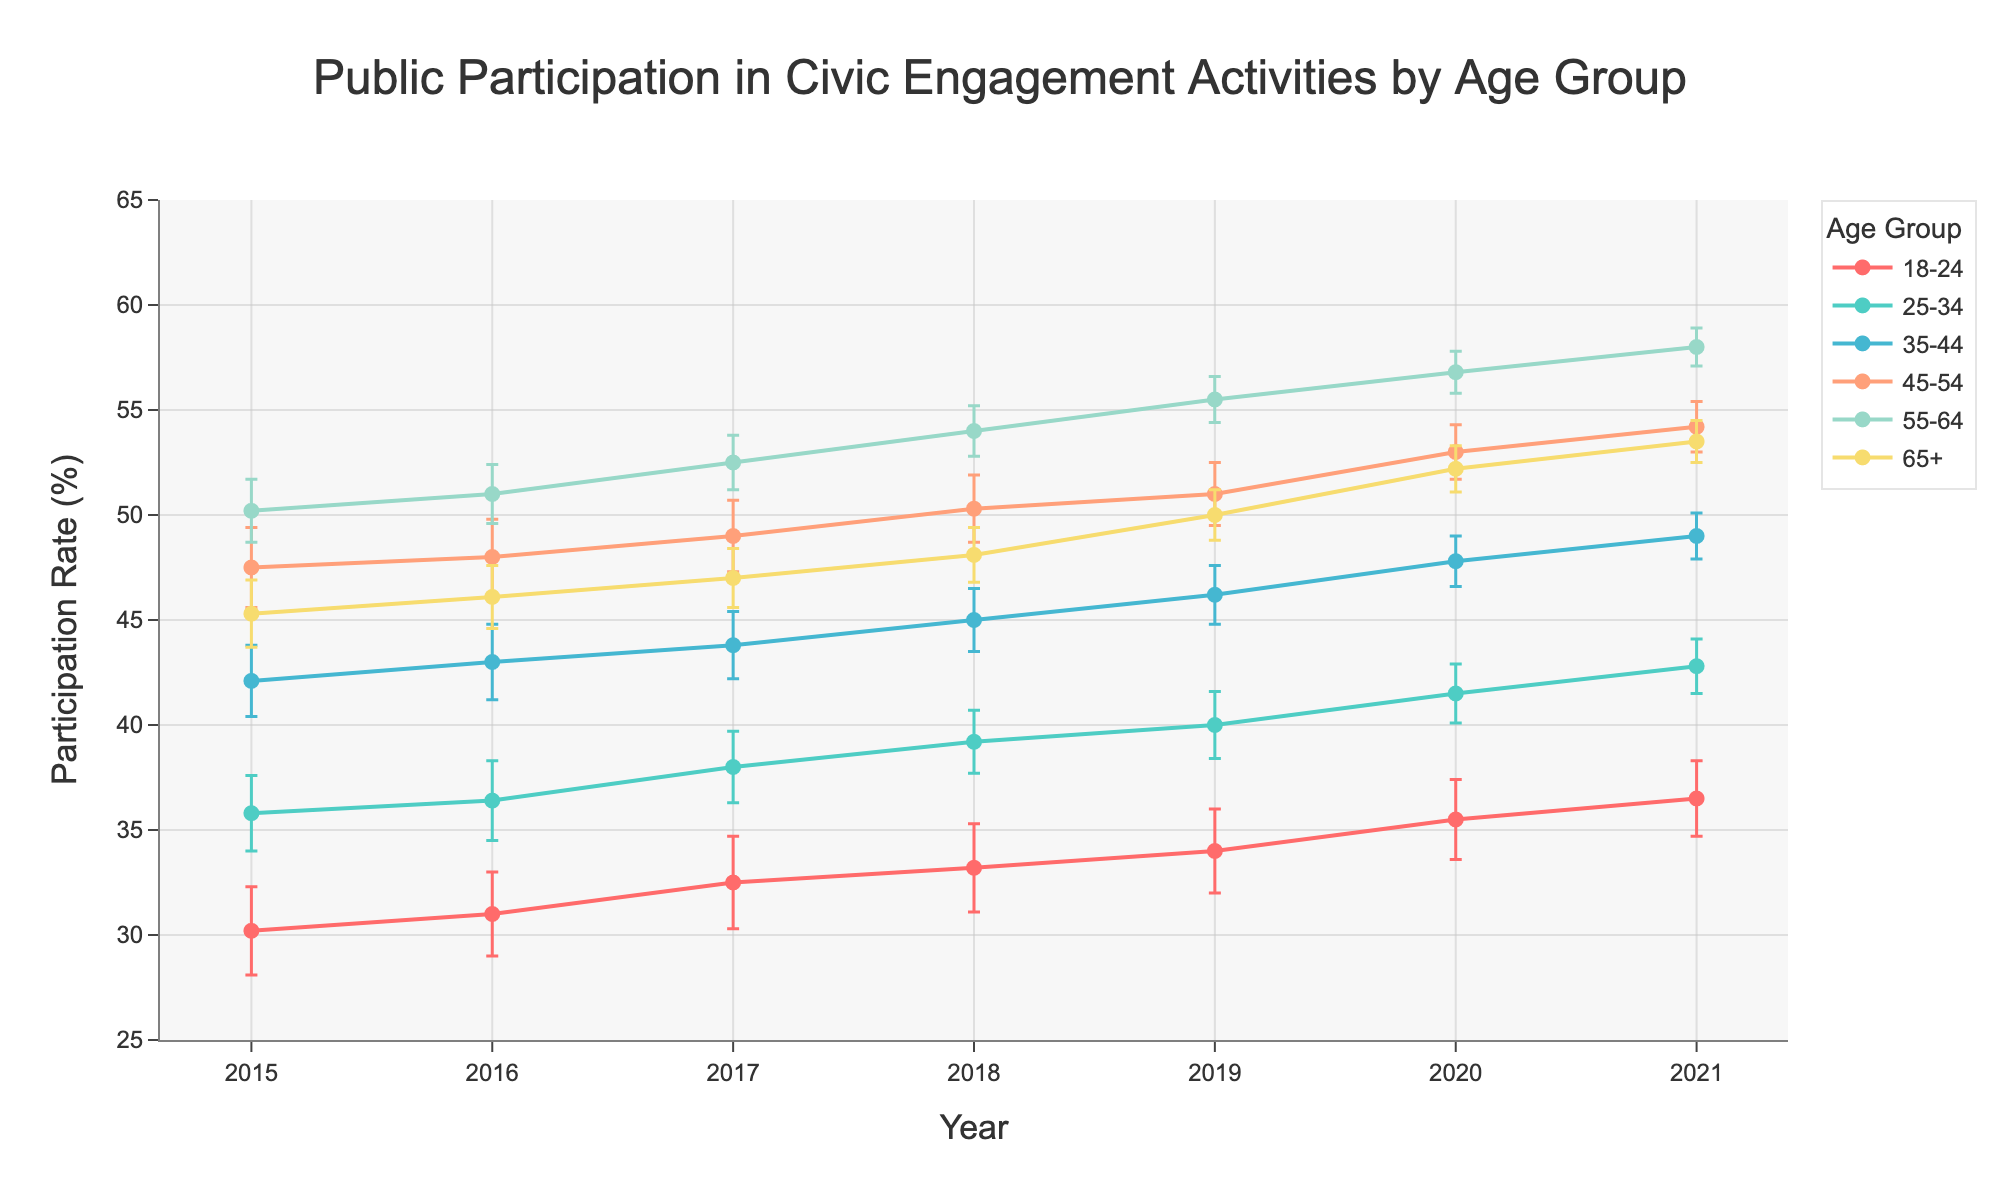What is the title of the line plot? The title of the plot is displayed at the top center of the figure, which reads "Public Participation in Civic Engagement Activities by Age Group".
Answer: Public Participation in Civic Engagement Activities by Age Group Which age group had the highest participation rate in 2021? To figure this out, we look at the values for all age groups in 2021 and find the highest one. The highest participation rate in 2021 is 58.0% for the 55-64 age group.
Answer: 55-64 What is the general trend in participation rate for the 18-24 age group from 2015 to 2021? Observing the line for the 18-24 age group from 2015 to 2021, we see a steady upward trend in participation rates each year.
Answer: Increase What was the difference in participation rate for the 45-54 age group between 2019 and 2021? The participation rate for 2019 in the 45-54 age group was 51.0%. In 2021, it was 54.2%. The difference is found by subtracting the 2019 rate from the 2021 rate (54.2 - 51.0 = 3.2).
Answer: 3.2% Between 2015 and 2021, which age group showed the smallest change in participation rate? We calculate the change for each group by subtracting the 2015 value from the 2021 value, then identify the smallest one. The 65+ age group changed from 45.3% in 2015 to 53.5% in 2021 (53.5 - 45.3 = 8.2), which is the smallest change compared to other age groups.
Answer: 65+ In 2020, which age group had the largest error margin? The error bars indicate the level of uncertainty. From the data in 2020, age group 18-24 has the largest error margin of 1.9%.
Answer: 18-24 By how much did the participation rate of the 25-34 age group increase from 2015 to 2021? The participation rate for the 25-34 age group in 2015 was 35.8%, and it increased to 42.8% in 2021. The increase is calculated as 42.8 - 35.8 = 7.0.
Answer: 7.0% Which age group consistently had the highest participation rate each year from 2015 to 2021? By examining the line plot across all years, we see that the 55-64 age group consistently has the highest participation rates in each year.
Answer: 55-64 What's the average participation rate for the 35-44 age group over the years 2015 to 2021? We sum up the participation rates for the 35-44 age group from 2015 to 2021 (42.1 + 43.0 + 43.8 + 45.0 + 46.2 + 47.8 + 49.0) = 316.9 and divide by the number of years (316.9 / 7) = 45.27%.
Answer: 45.27% What noticeable trend is seen in participation rates for the 55-64 age group from 2015 to 2021? Observing the 55-64 age group's line on the plot, a steady increase in participation rates is seen from 2015 (50.2%) to 2021 (58.0%).
Answer: Steady increase 